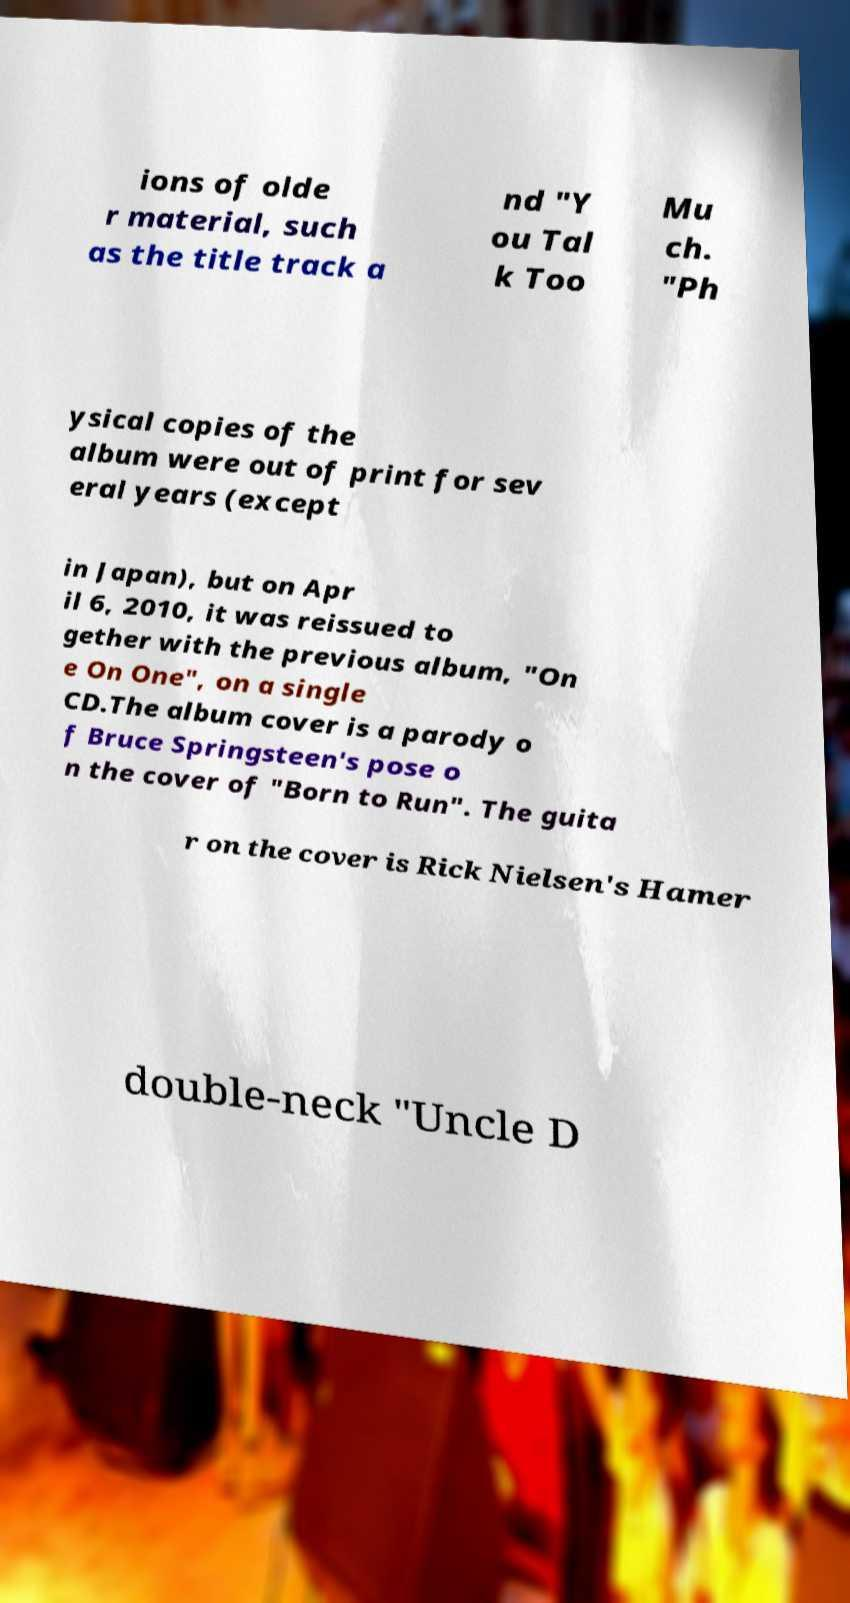There's text embedded in this image that I need extracted. Can you transcribe it verbatim? ions of olde r material, such as the title track a nd "Y ou Tal k Too Mu ch. "Ph ysical copies of the album were out of print for sev eral years (except in Japan), but on Apr il 6, 2010, it was reissued to gether with the previous album, "On e On One", on a single CD.The album cover is a parody o f Bruce Springsteen's pose o n the cover of "Born to Run". The guita r on the cover is Rick Nielsen's Hamer double-neck "Uncle D 